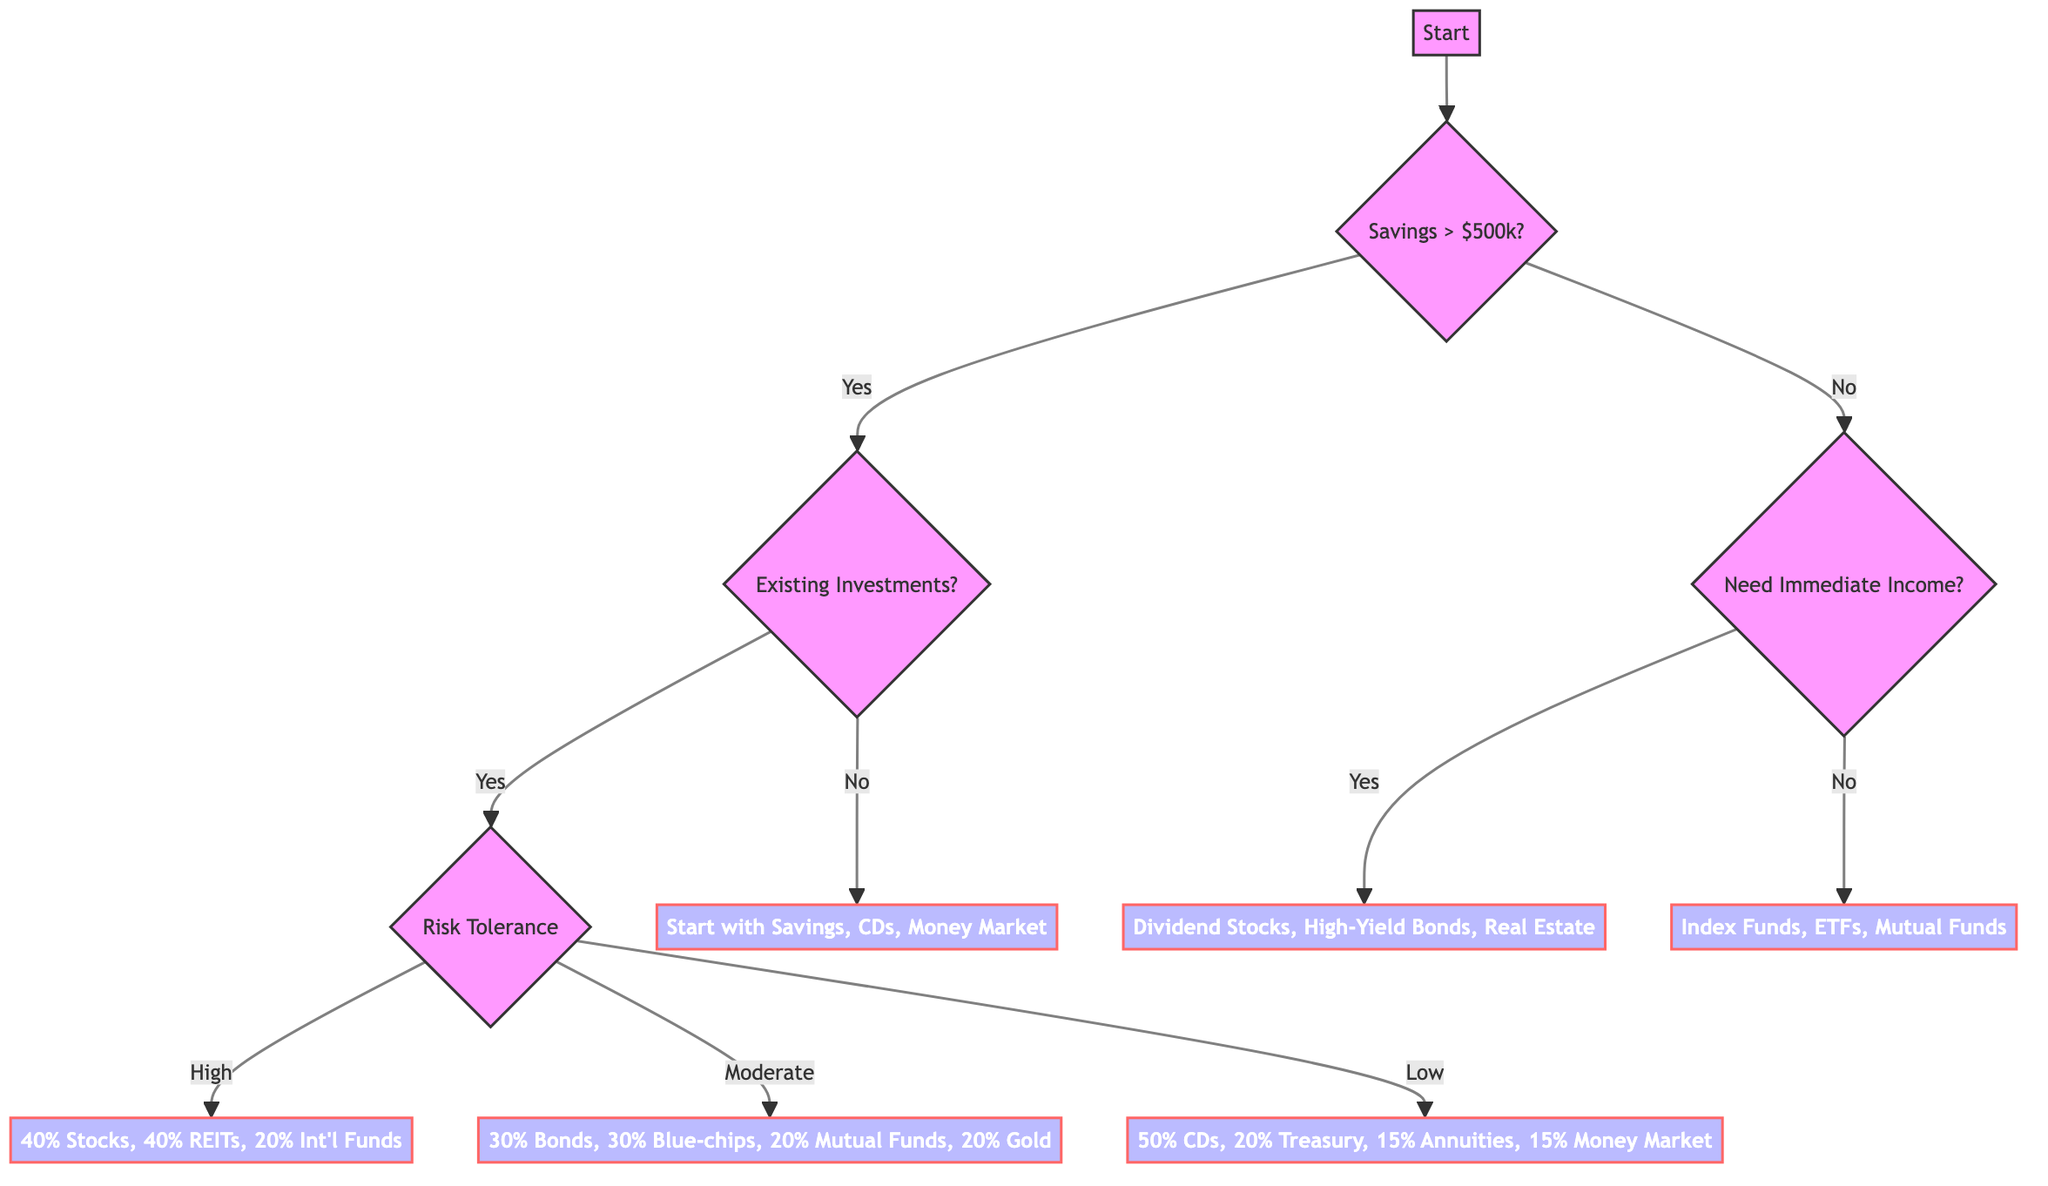How many main branches are there in the decision tree? The decision tree has two main branches: one for savings greater than $500,000 and another for savings less than $500,000.
Answer: 2 What investments should you start with if you have less than $500,000 and need immediate income? If you need immediate income and have less than $500,000, the decision leads to focusing on income-generating investments like Dividend-Paying Stocks, High-Yield Bonds, and Real Estate.
Answer: Income Investments What is the suggested portfolio allocation for someone with existing investments and a high risk tolerance? If a person has existing investments and a high risk tolerance, the decision tree suggests a portfolio allocation of 40% Stocks, 40% Real Estate, and 20% International Funds.
Answer: 40% Stocks, 40% Real Estate, 20% International Funds If you have existing investments and a low risk tolerance, what is the recommended allocation? The recommended portfolio for someone with existing investments and low risk tolerance is 50% Certificates of Deposit, 20% Treasury Bonds, 15% Fixed Annuities, and 15% Money Market Funds.
Answer: 50% CDs, 20% Treasury Bonds, 15% Annuities, 15% Money Market What is the first question you are asked at the start of the decision tree? At the start of the decision tree, you are asked how much savings you have, specifically if it is more than $500,000 or less than $500,000.
Answer: How much savings do you have? (More than $500,000 / Less than $500,000) What happens if you have more than $500,000 but no existing investments? If you have more than $500,000 but no existing investments, you are advised to start with conservative investments like Savings Accounts, CDs, and Money Market Funds, and then assess your risk tolerance.
Answer: Start Conservative 